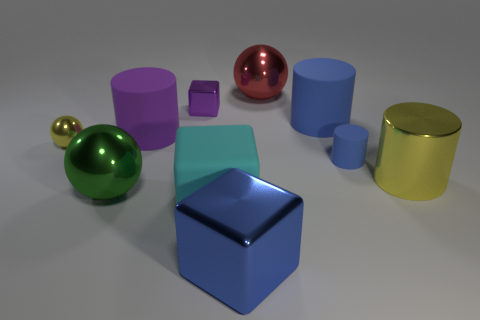What number of yellow things have the same material as the small cube?
Ensure brevity in your answer.  2. Are there more big cylinders than tiny blue matte objects?
Give a very brief answer. Yes. There is a yellow shiny object that is on the left side of the matte block; how many large rubber cylinders are in front of it?
Offer a very short reply. 0. What number of objects are either matte things right of the big metallic block or tiny metal spheres?
Make the answer very short. 3. Is there a big gray rubber object that has the same shape as the small purple metallic object?
Give a very brief answer. No. What shape is the large green metal thing behind the matte thing in front of the big yellow cylinder?
Offer a very short reply. Sphere. What number of cylinders are either gray matte things or tiny blue matte things?
Offer a terse response. 1. There is another cylinder that is the same color as the small matte cylinder; what is it made of?
Offer a very short reply. Rubber. Do the big cyan matte thing that is to the right of the small purple shiny cube and the big blue object in front of the big cyan block have the same shape?
Your answer should be very brief. Yes. What is the color of the block that is to the left of the blue cube and in front of the green object?
Make the answer very short. Cyan. 